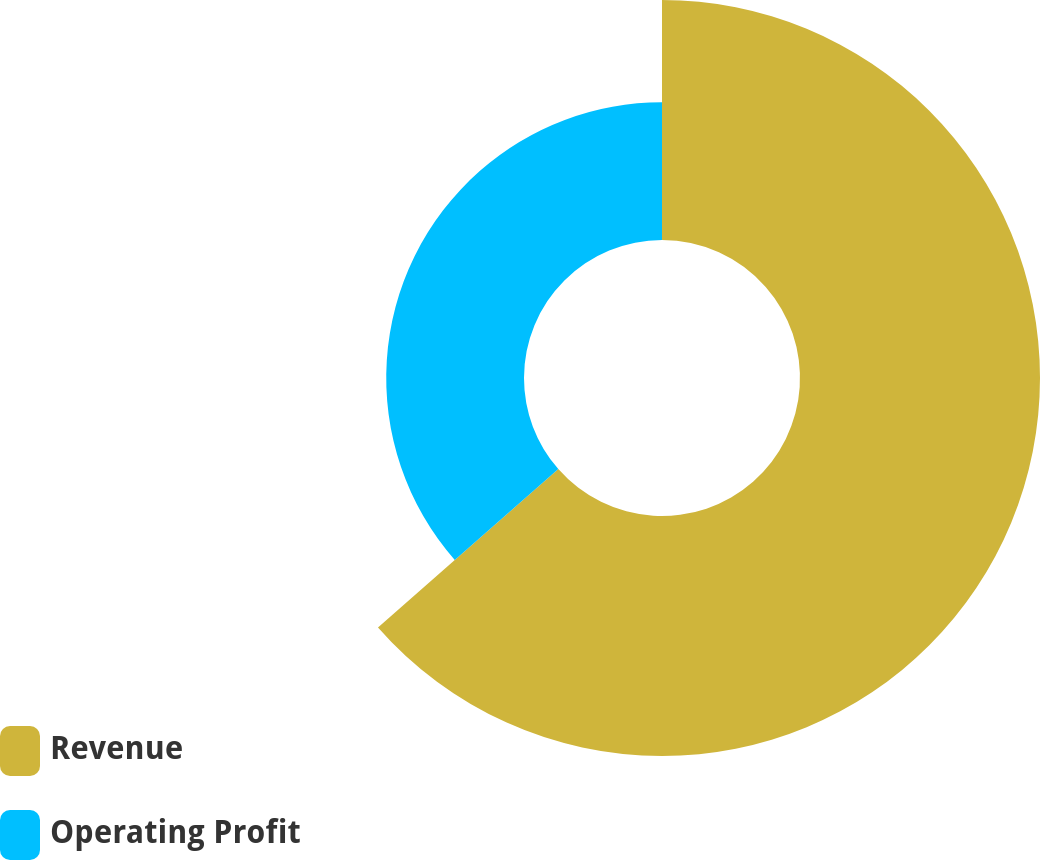<chart> <loc_0><loc_0><loc_500><loc_500><pie_chart><fcel>Revenue<fcel>Operating Profit<nl><fcel>63.53%<fcel>36.47%<nl></chart> 